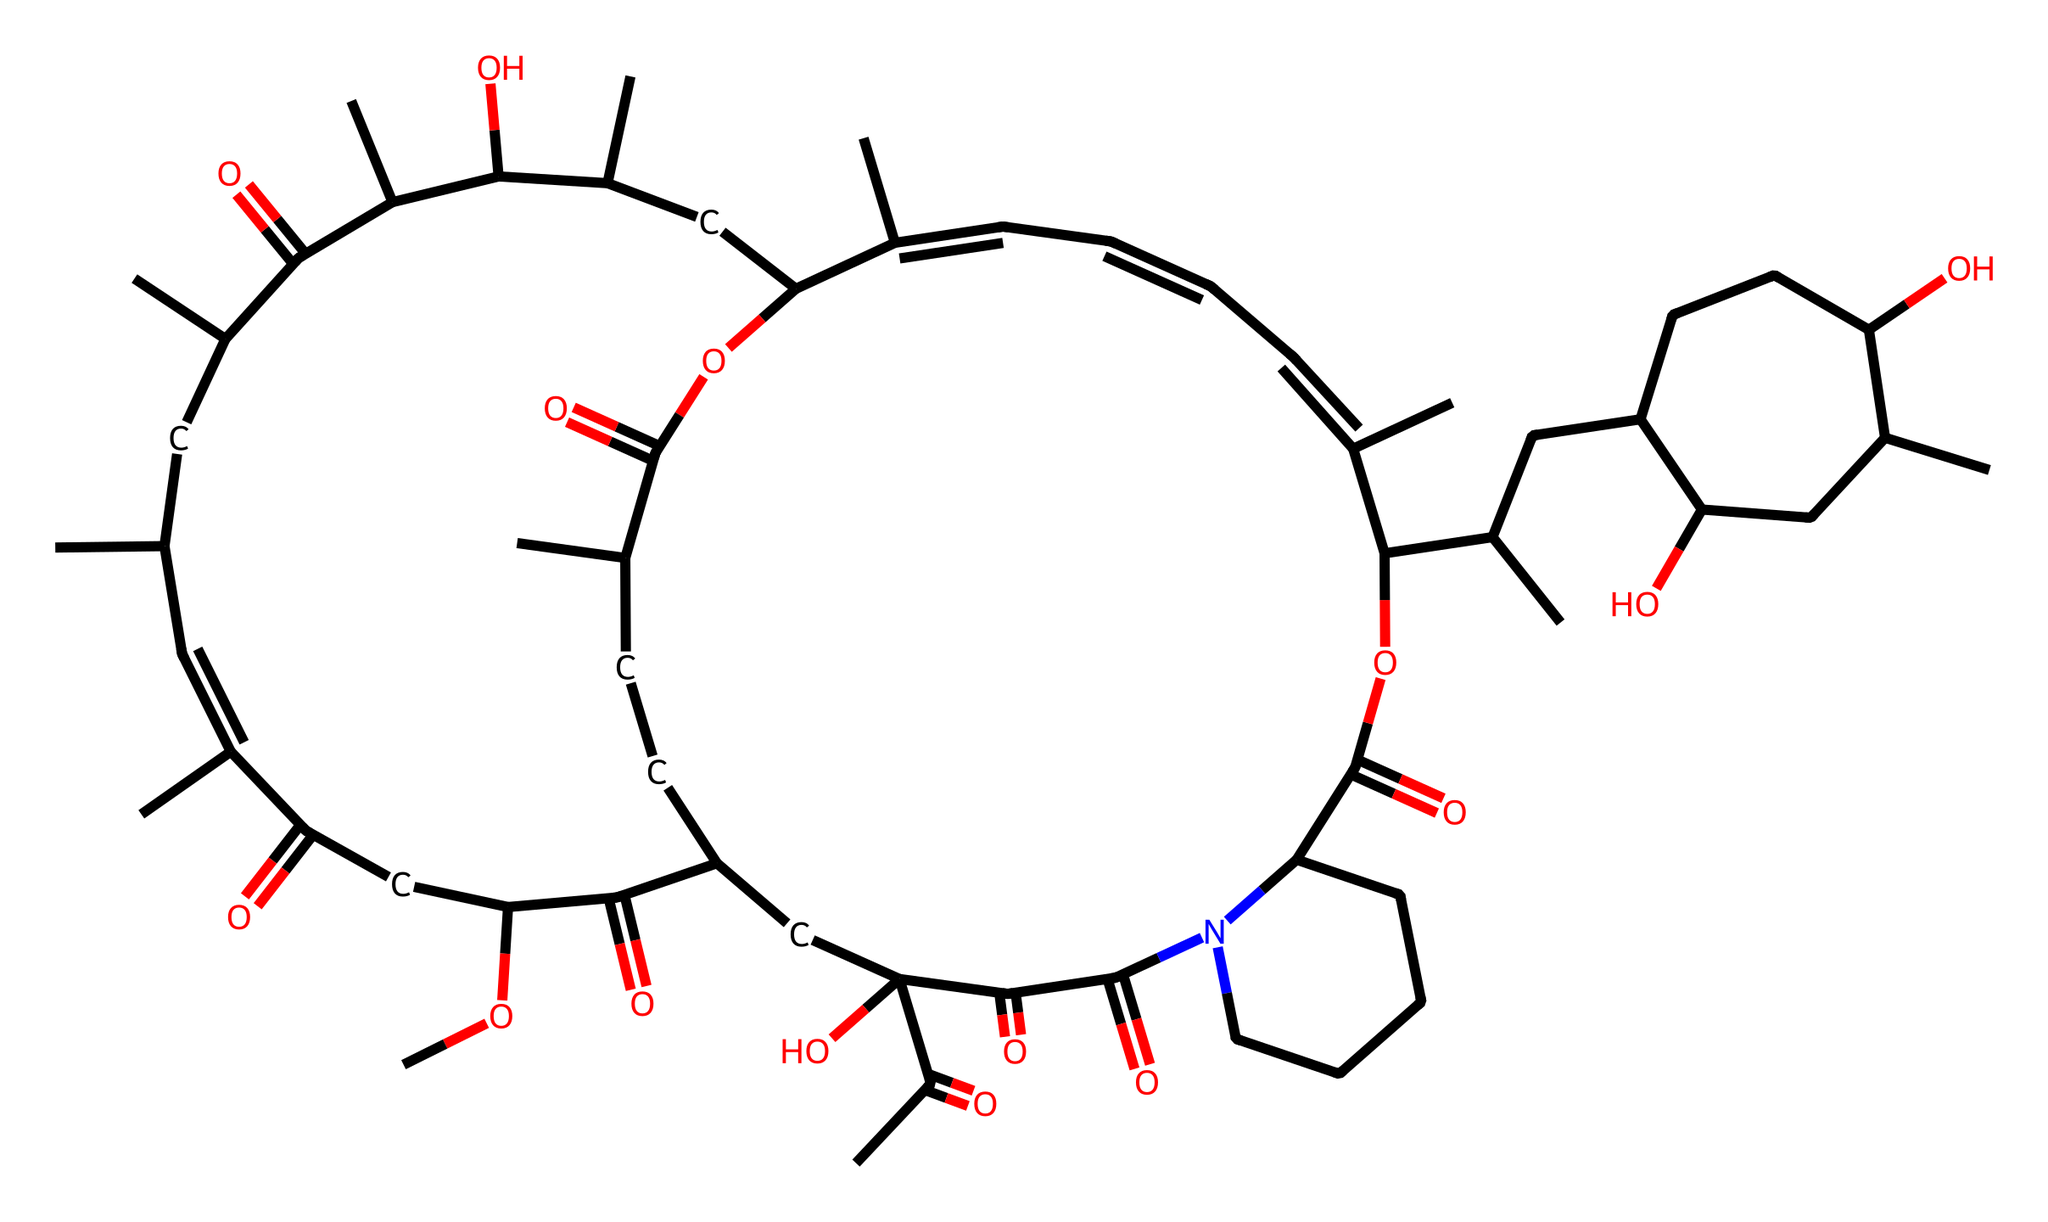What is the molecular formula of rapamycin? To determine the molecular formula, we need to count all the carbon (C), hydrogen (H), nitrogen (N), and oxygen (O) atoms in the SMILES representation. The chemical structure of rapamycin has 42 carbons, 59 hydrogens, 1 nitrogen, and 10 oxygens, leading to the molecular formula C42H59N1O10.
Answer: C42H59N1O10 How many rings are present in rapamycin's structure? By analyzing the SMILES, we identify the presence of curly brackets that denote ring structures in the chemical. There are two closed cycles in rapamycin’s structure.
Answer: 2 What type of functional groups are present in rapamycin? The analysis of the SMILES indicates the presence of multiple functional groups, such as hydroxyl (-OH) and carbonyl (C=O) groups, which can be identified by their distinct notations in the structure. Rapamycin has alcohol and amide functional groups amongst others.
Answer: alcohol, amide Is rapamycin a polar or nonpolar compound? Given the numerous polar functional groups such as hydroxyl and carbonyl, and considering their influence on the overall structure, rapamycin is classified as a polar compound due to its higher number of polar groups compared to nonpolar components.
Answer: polar What is the effect of rapamycin on the immune system? Rapamycin acts as an immunosuppressant by inhibiting the mTOR pathway, which is critical for cell growth and proliferation in immune responses. This inhibition results in decreased lymphocyte activation and proliferation.
Answer: immunosuppressant Does rapamycin have potential anticancer properties? Yes, rapamycin has shown potential anticancer properties through its ability to inhibit the mTOR pathway, leading to reduced cancer cell proliferation and survival, making it a subject of interest in cancer research.
Answer: yes 